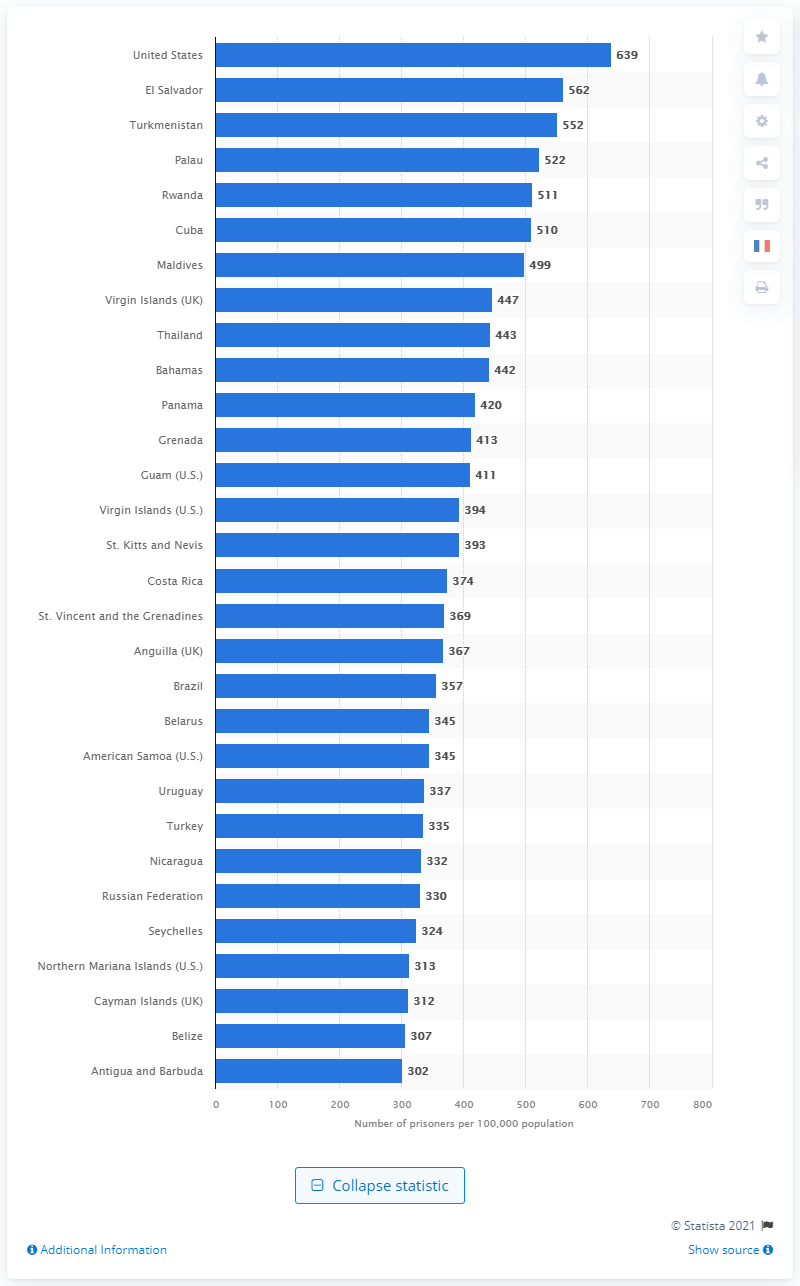Point out several critical features in this image. The United States had 639 prisoners per 100,000 of its population in May 2021. 